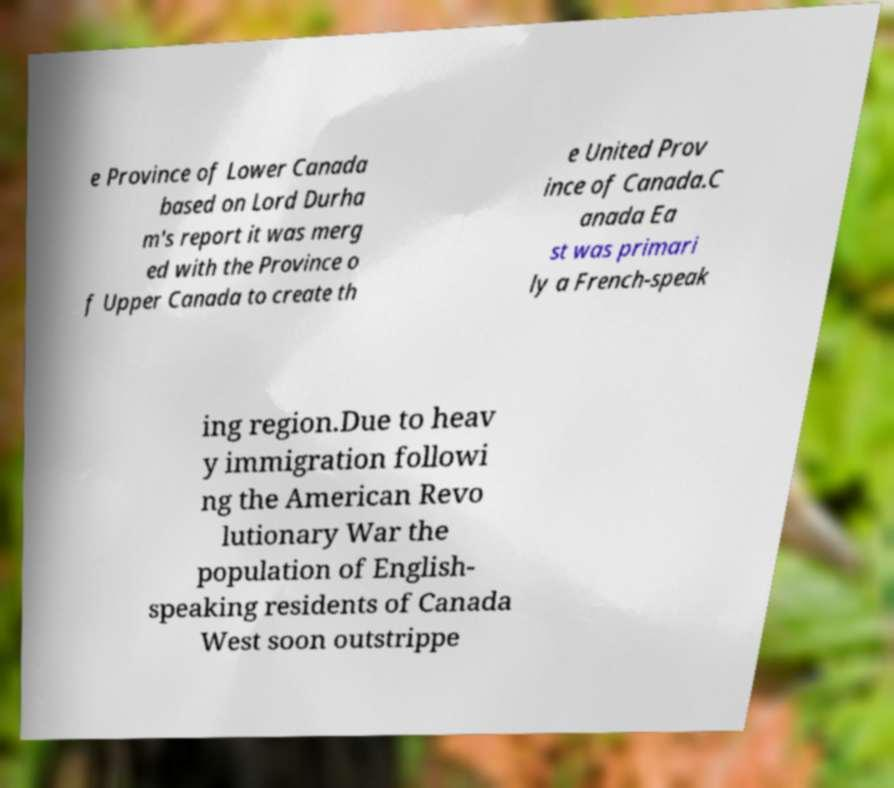There's text embedded in this image that I need extracted. Can you transcribe it verbatim? e Province of Lower Canada based on Lord Durha m's report it was merg ed with the Province o f Upper Canada to create th e United Prov ince of Canada.C anada Ea st was primari ly a French-speak ing region.Due to heav y immigration followi ng the American Revo lutionary War the population of English- speaking residents of Canada West soon outstrippe 